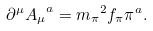<formula> <loc_0><loc_0><loc_500><loc_500>\partial ^ { \mu } { A _ { \mu } } ^ { a } = { m _ { \pi } } ^ { 2 } f _ { \pi } \pi ^ { a } .</formula> 